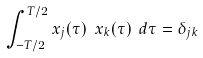<formula> <loc_0><loc_0><loc_500><loc_500>\int _ { - T / 2 } ^ { T / 2 } x _ { j } ( \tau ) \ x _ { k } ( \tau ) \ d \tau = \delta _ { j k }</formula> 